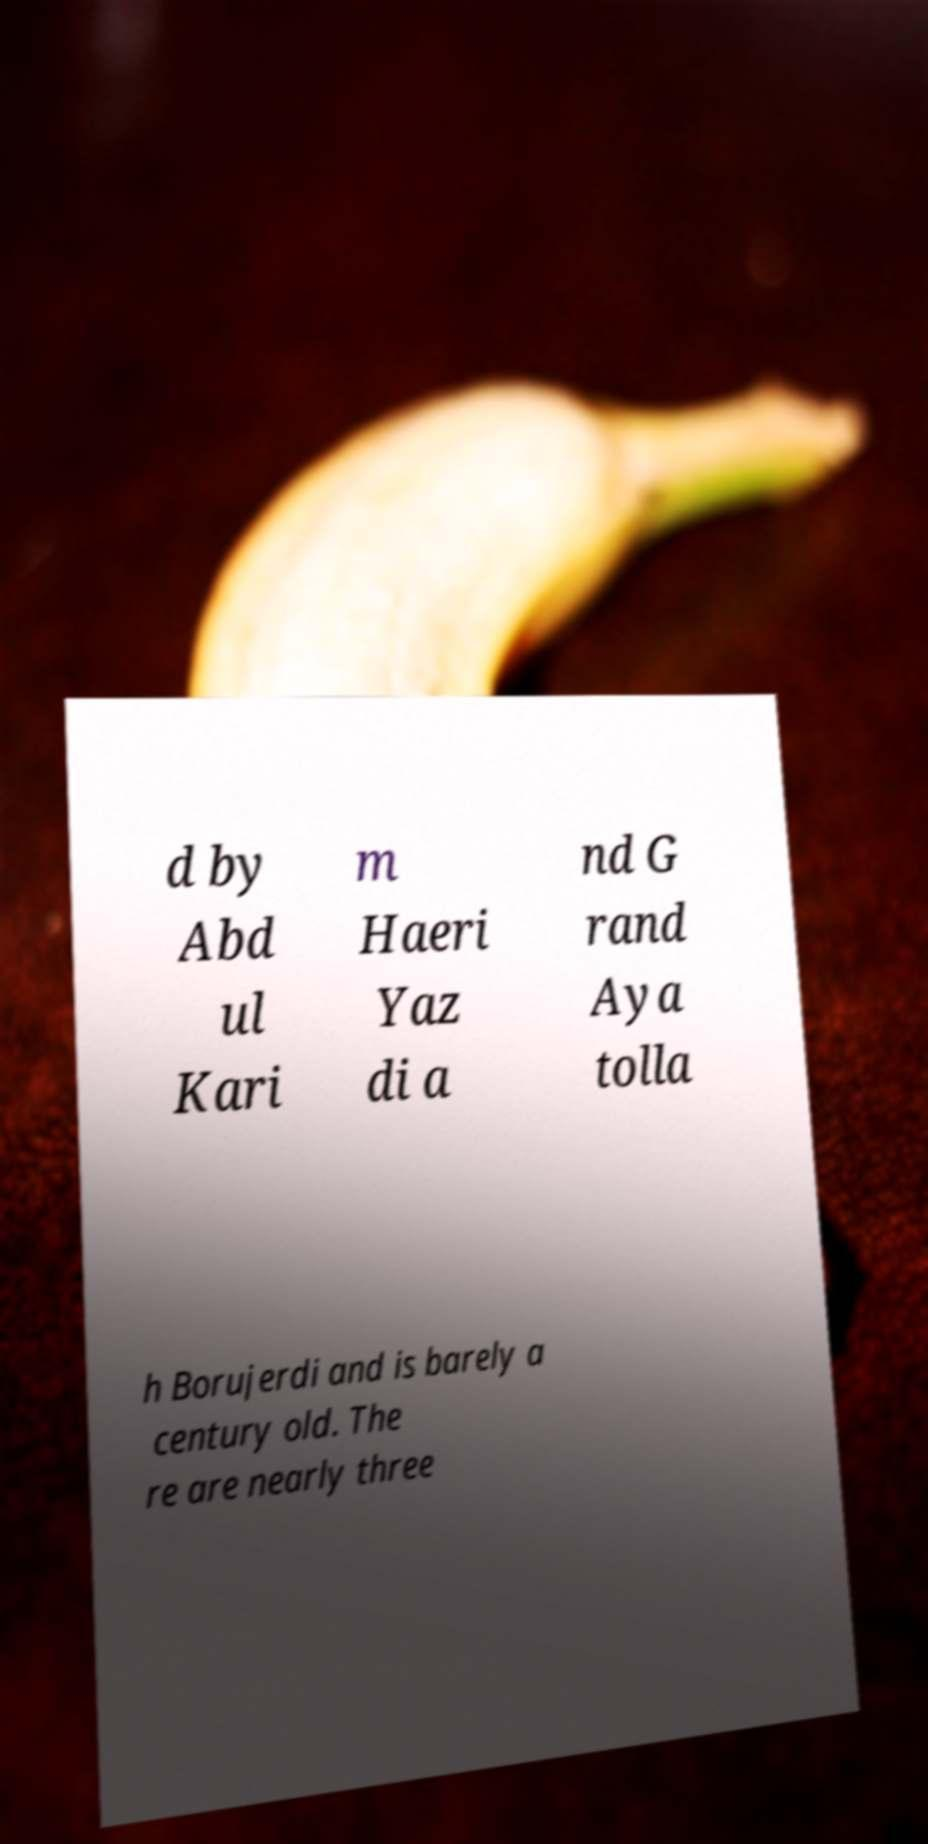Could you extract and type out the text from this image? d by Abd ul Kari m Haeri Yaz di a nd G rand Aya tolla h Borujerdi and is barely a century old. The re are nearly three 